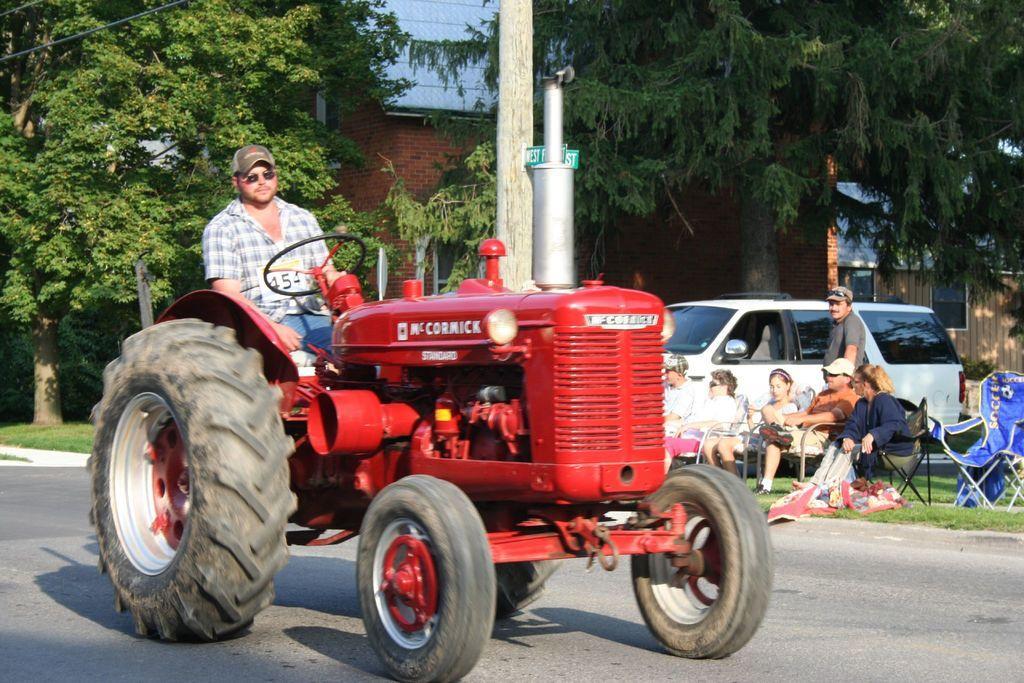Describe this image in one or two sentences. In this image in front there is a road. There is a person sitting on the tractor. On the right side of the image there are people sitting on the chairs. Behind them there is a car. At the bottom of the image there is grass on the surface. In the background of the image there are trees and buildings. 